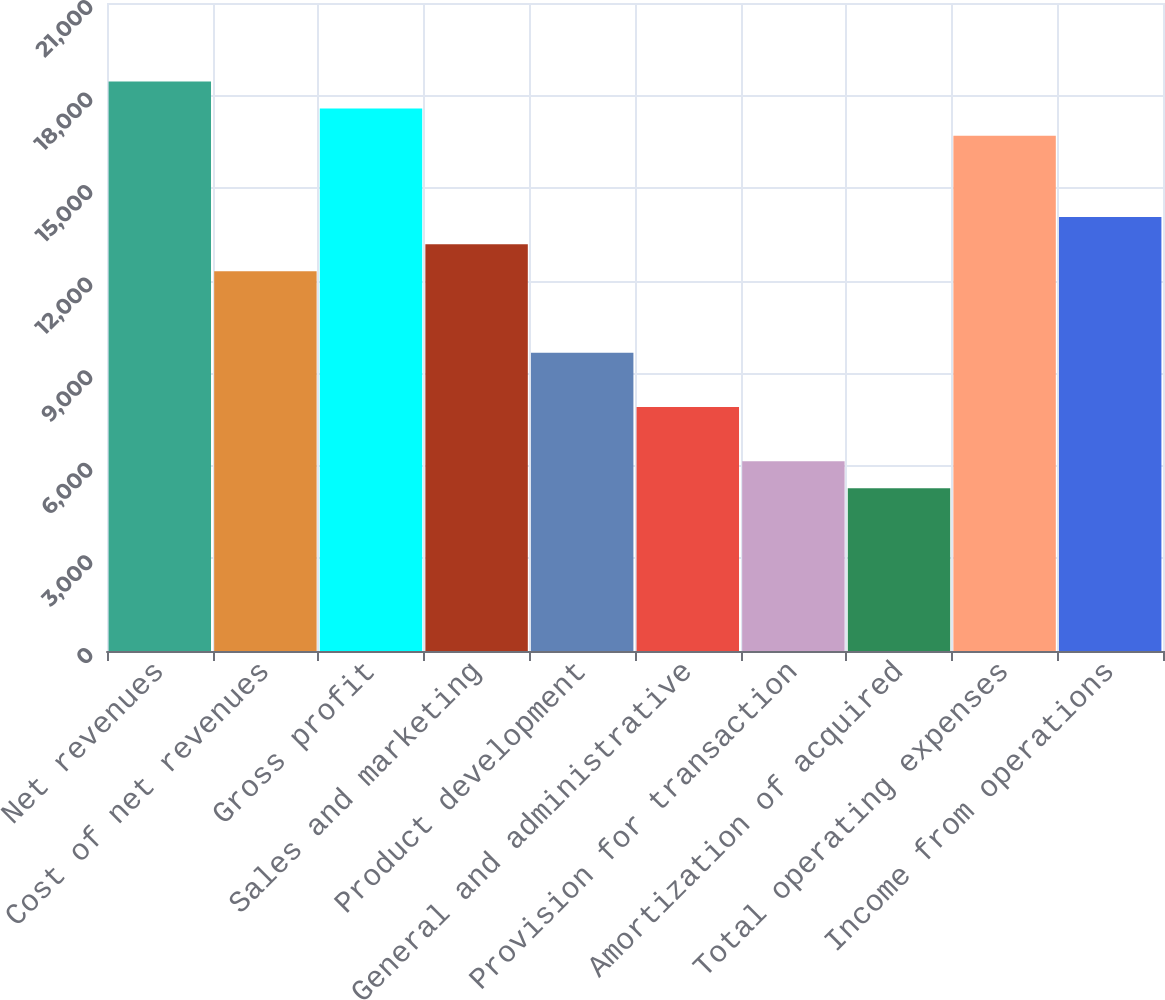Convert chart. <chart><loc_0><loc_0><loc_500><loc_500><bar_chart><fcel>Net revenues<fcel>Cost of net revenues<fcel>Gross profit<fcel>Sales and marketing<fcel>Product development<fcel>General and administrative<fcel>Provision for transaction<fcel>Amortization of acquired<fcel>Total operating expenses<fcel>Income from operations<nl><fcel>18459<fcel>12306<fcel>17580<fcel>13185<fcel>9669.04<fcel>7911.04<fcel>6153.04<fcel>5274.04<fcel>16701<fcel>14064<nl></chart> 